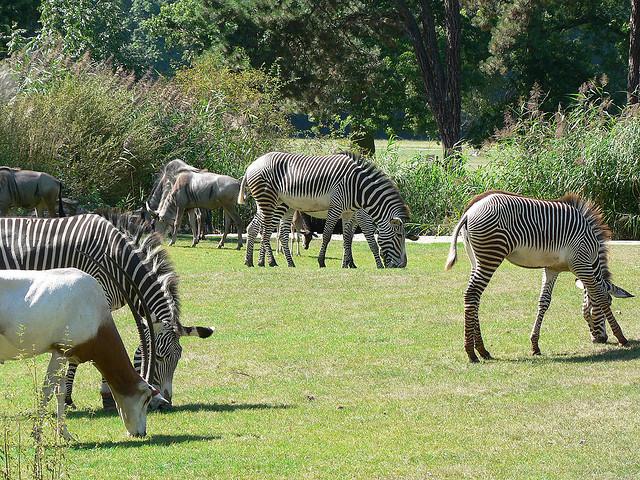What are the zebra's eating?
Write a very short answer. Grass. Are these animals from Australia?
Short answer required. No. What is the brown and white animal?
Answer briefly. Cow. 